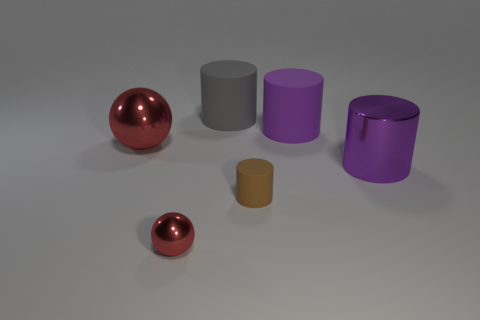Add 4 metal things. How many objects exist? 10 Subtract all balls. How many objects are left? 4 Subtract all big green cubes. Subtract all matte cylinders. How many objects are left? 3 Add 4 tiny red objects. How many tiny red objects are left? 5 Add 2 small cylinders. How many small cylinders exist? 3 Subtract 0 green spheres. How many objects are left? 6 